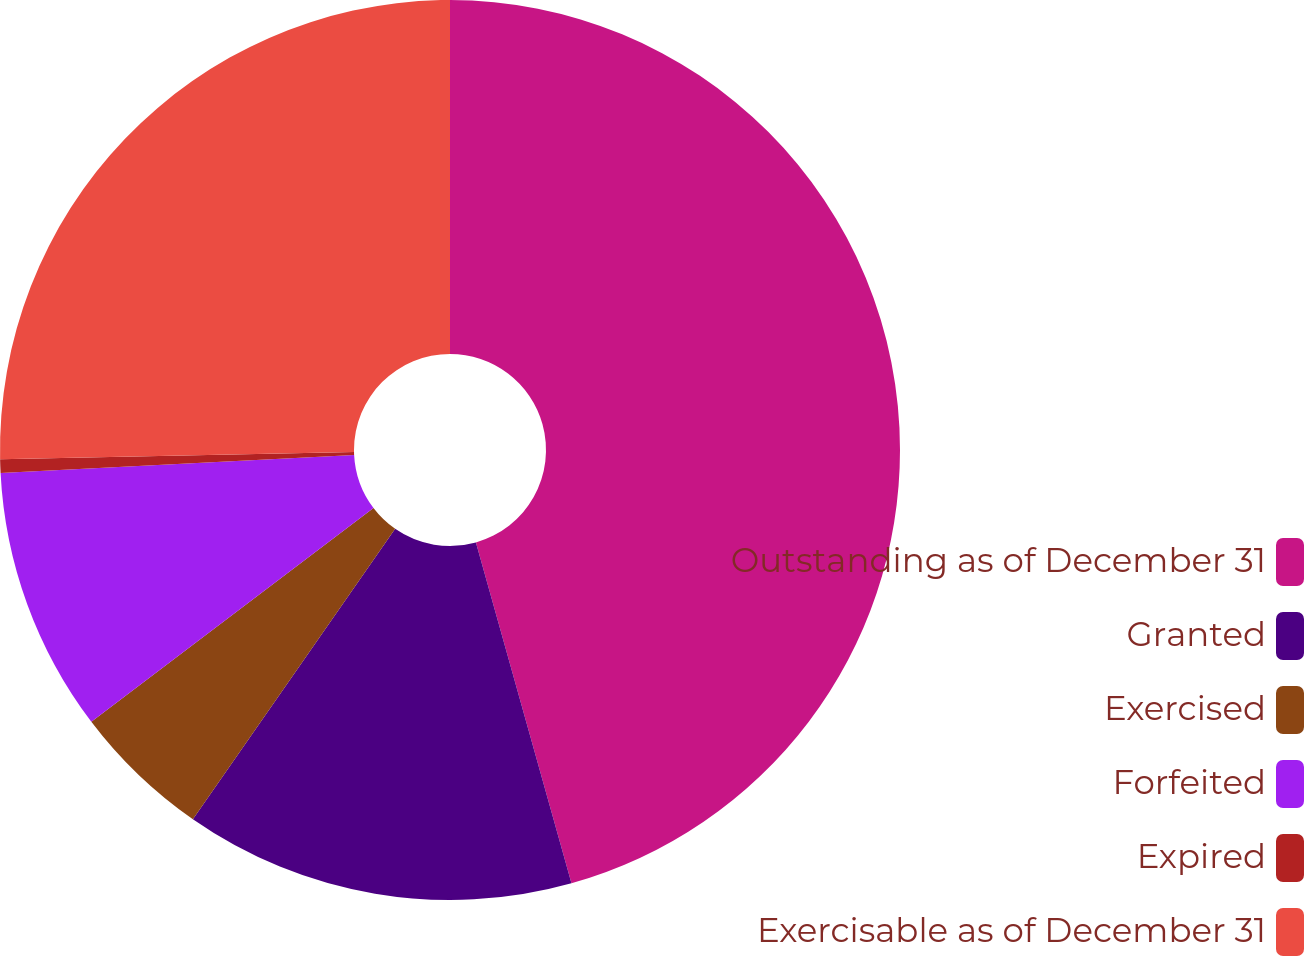<chart> <loc_0><loc_0><loc_500><loc_500><pie_chart><fcel>Outstanding as of December 31<fcel>Granted<fcel>Exercised<fcel>Forfeited<fcel>Expired<fcel>Exercisable as of December 31<nl><fcel>45.65%<fcel>14.03%<fcel>5.0%<fcel>9.51%<fcel>0.48%<fcel>25.33%<nl></chart> 